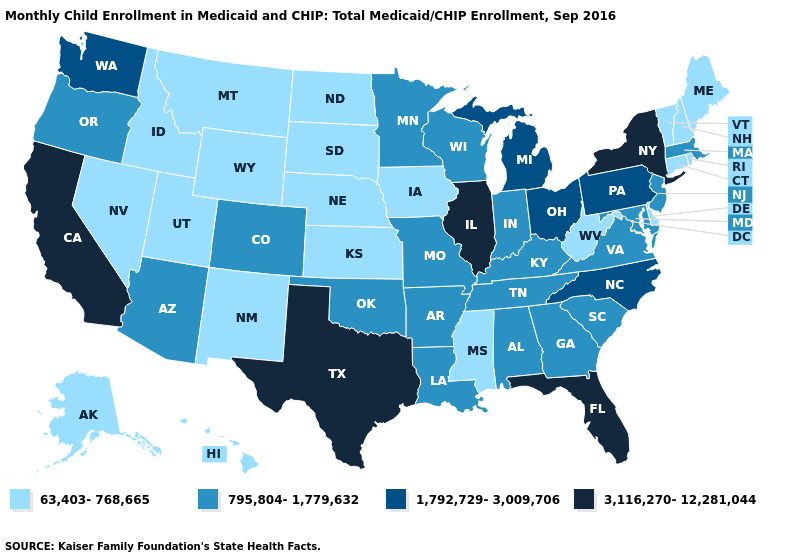Does Wisconsin have a lower value than California?
Quick response, please. Yes. What is the highest value in the USA?
Answer briefly. 3,116,270-12,281,044. Does Montana have the same value as Washington?
Quick response, please. No. What is the lowest value in the USA?
Concise answer only. 63,403-768,665. Among the states that border Georgia , which have the lowest value?
Write a very short answer. Alabama, South Carolina, Tennessee. Name the states that have a value in the range 1,792,729-3,009,706?
Write a very short answer. Michigan, North Carolina, Ohio, Pennsylvania, Washington. Name the states that have a value in the range 3,116,270-12,281,044?
Give a very brief answer. California, Florida, Illinois, New York, Texas. Does Rhode Island have the lowest value in the Northeast?
Write a very short answer. Yes. Does Florida have the lowest value in the USA?
Keep it brief. No. What is the highest value in the Northeast ?
Give a very brief answer. 3,116,270-12,281,044. Name the states that have a value in the range 1,792,729-3,009,706?
Quick response, please. Michigan, North Carolina, Ohio, Pennsylvania, Washington. Name the states that have a value in the range 1,792,729-3,009,706?
Quick response, please. Michigan, North Carolina, Ohio, Pennsylvania, Washington. Name the states that have a value in the range 3,116,270-12,281,044?
Give a very brief answer. California, Florida, Illinois, New York, Texas. Does Missouri have the same value as Alabama?
Short answer required. Yes. What is the value of California?
Give a very brief answer. 3,116,270-12,281,044. 